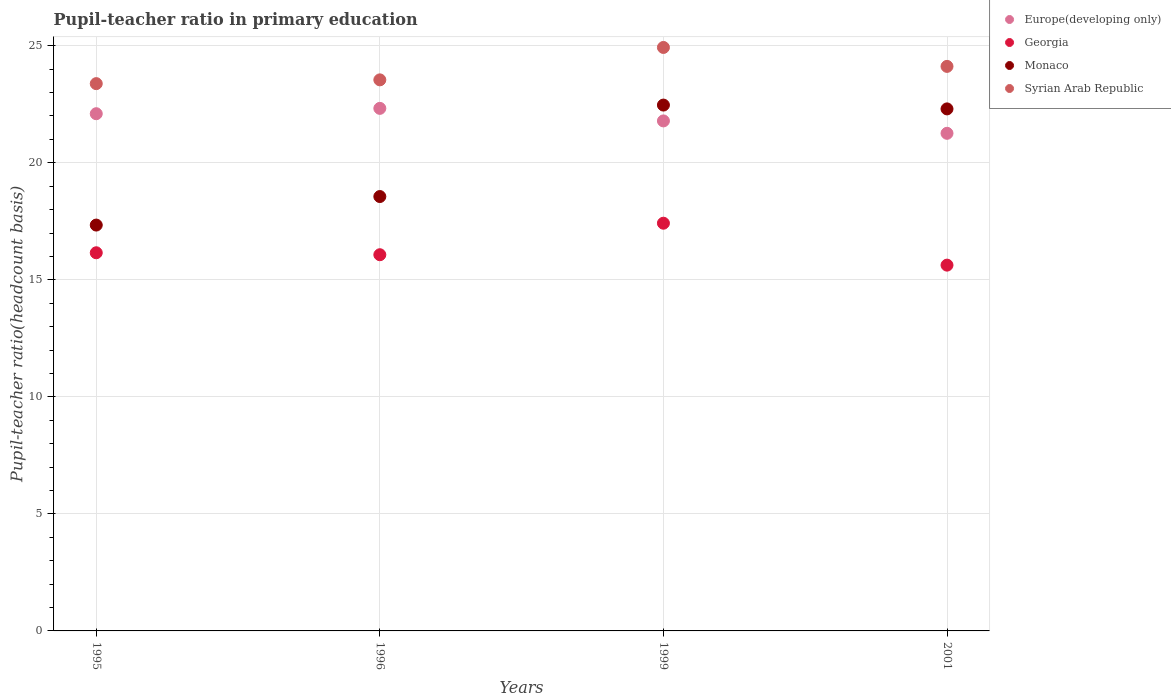What is the pupil-teacher ratio in primary education in Monaco in 2001?
Ensure brevity in your answer.  22.3. Across all years, what is the maximum pupil-teacher ratio in primary education in Syrian Arab Republic?
Keep it short and to the point. 24.93. Across all years, what is the minimum pupil-teacher ratio in primary education in Syrian Arab Republic?
Your response must be concise. 23.38. In which year was the pupil-teacher ratio in primary education in Monaco maximum?
Provide a succinct answer. 1999. What is the total pupil-teacher ratio in primary education in Monaco in the graph?
Offer a very short reply. 80.67. What is the difference between the pupil-teacher ratio in primary education in Europe(developing only) in 1996 and that in 1999?
Offer a terse response. 0.54. What is the difference between the pupil-teacher ratio in primary education in Syrian Arab Republic in 1999 and the pupil-teacher ratio in primary education in Monaco in 1996?
Your response must be concise. 6.37. What is the average pupil-teacher ratio in primary education in Syrian Arab Republic per year?
Ensure brevity in your answer.  23.99. In the year 1996, what is the difference between the pupil-teacher ratio in primary education in Europe(developing only) and pupil-teacher ratio in primary education in Monaco?
Provide a short and direct response. 3.77. What is the ratio of the pupil-teacher ratio in primary education in Georgia in 1995 to that in 2001?
Keep it short and to the point. 1.03. Is the difference between the pupil-teacher ratio in primary education in Europe(developing only) in 1996 and 1999 greater than the difference between the pupil-teacher ratio in primary education in Monaco in 1996 and 1999?
Ensure brevity in your answer.  Yes. What is the difference between the highest and the second highest pupil-teacher ratio in primary education in Europe(developing only)?
Provide a short and direct response. 0.23. What is the difference between the highest and the lowest pupil-teacher ratio in primary education in Syrian Arab Republic?
Provide a short and direct response. 1.55. In how many years, is the pupil-teacher ratio in primary education in Monaco greater than the average pupil-teacher ratio in primary education in Monaco taken over all years?
Make the answer very short. 2. Is the pupil-teacher ratio in primary education in Georgia strictly greater than the pupil-teacher ratio in primary education in Syrian Arab Republic over the years?
Your answer should be very brief. No. Are the values on the major ticks of Y-axis written in scientific E-notation?
Your answer should be compact. No. How many legend labels are there?
Your answer should be compact. 4. What is the title of the graph?
Offer a terse response. Pupil-teacher ratio in primary education. Does "Ukraine" appear as one of the legend labels in the graph?
Offer a terse response. No. What is the label or title of the X-axis?
Your response must be concise. Years. What is the label or title of the Y-axis?
Make the answer very short. Pupil-teacher ratio(headcount basis). What is the Pupil-teacher ratio(headcount basis) of Europe(developing only) in 1995?
Your response must be concise. 22.1. What is the Pupil-teacher ratio(headcount basis) in Georgia in 1995?
Provide a succinct answer. 16.16. What is the Pupil-teacher ratio(headcount basis) of Monaco in 1995?
Make the answer very short. 17.34. What is the Pupil-teacher ratio(headcount basis) in Syrian Arab Republic in 1995?
Provide a short and direct response. 23.38. What is the Pupil-teacher ratio(headcount basis) of Europe(developing only) in 1996?
Your answer should be very brief. 22.33. What is the Pupil-teacher ratio(headcount basis) of Georgia in 1996?
Give a very brief answer. 16.07. What is the Pupil-teacher ratio(headcount basis) in Monaco in 1996?
Your answer should be very brief. 18.56. What is the Pupil-teacher ratio(headcount basis) of Syrian Arab Republic in 1996?
Give a very brief answer. 23.54. What is the Pupil-teacher ratio(headcount basis) of Europe(developing only) in 1999?
Provide a short and direct response. 21.79. What is the Pupil-teacher ratio(headcount basis) of Georgia in 1999?
Give a very brief answer. 17.42. What is the Pupil-teacher ratio(headcount basis) of Monaco in 1999?
Give a very brief answer. 22.47. What is the Pupil-teacher ratio(headcount basis) of Syrian Arab Republic in 1999?
Ensure brevity in your answer.  24.93. What is the Pupil-teacher ratio(headcount basis) of Europe(developing only) in 2001?
Offer a terse response. 21.26. What is the Pupil-teacher ratio(headcount basis) of Georgia in 2001?
Your answer should be compact. 15.63. What is the Pupil-teacher ratio(headcount basis) in Monaco in 2001?
Give a very brief answer. 22.3. What is the Pupil-teacher ratio(headcount basis) in Syrian Arab Republic in 2001?
Your answer should be very brief. 24.12. Across all years, what is the maximum Pupil-teacher ratio(headcount basis) of Europe(developing only)?
Your answer should be very brief. 22.33. Across all years, what is the maximum Pupil-teacher ratio(headcount basis) in Georgia?
Provide a succinct answer. 17.42. Across all years, what is the maximum Pupil-teacher ratio(headcount basis) of Monaco?
Offer a terse response. 22.47. Across all years, what is the maximum Pupil-teacher ratio(headcount basis) of Syrian Arab Republic?
Make the answer very short. 24.93. Across all years, what is the minimum Pupil-teacher ratio(headcount basis) of Europe(developing only)?
Keep it short and to the point. 21.26. Across all years, what is the minimum Pupil-teacher ratio(headcount basis) in Georgia?
Offer a very short reply. 15.63. Across all years, what is the minimum Pupil-teacher ratio(headcount basis) of Monaco?
Offer a terse response. 17.34. Across all years, what is the minimum Pupil-teacher ratio(headcount basis) of Syrian Arab Republic?
Offer a very short reply. 23.38. What is the total Pupil-teacher ratio(headcount basis) of Europe(developing only) in the graph?
Ensure brevity in your answer.  87.47. What is the total Pupil-teacher ratio(headcount basis) of Georgia in the graph?
Your answer should be very brief. 65.28. What is the total Pupil-teacher ratio(headcount basis) of Monaco in the graph?
Make the answer very short. 80.67. What is the total Pupil-teacher ratio(headcount basis) of Syrian Arab Republic in the graph?
Provide a succinct answer. 95.97. What is the difference between the Pupil-teacher ratio(headcount basis) of Europe(developing only) in 1995 and that in 1996?
Your response must be concise. -0.23. What is the difference between the Pupil-teacher ratio(headcount basis) of Georgia in 1995 and that in 1996?
Give a very brief answer. 0.08. What is the difference between the Pupil-teacher ratio(headcount basis) in Monaco in 1995 and that in 1996?
Make the answer very short. -1.22. What is the difference between the Pupil-teacher ratio(headcount basis) of Syrian Arab Republic in 1995 and that in 1996?
Give a very brief answer. -0.16. What is the difference between the Pupil-teacher ratio(headcount basis) in Europe(developing only) in 1995 and that in 1999?
Ensure brevity in your answer.  0.31. What is the difference between the Pupil-teacher ratio(headcount basis) in Georgia in 1995 and that in 1999?
Your response must be concise. -1.26. What is the difference between the Pupil-teacher ratio(headcount basis) in Monaco in 1995 and that in 1999?
Offer a very short reply. -5.13. What is the difference between the Pupil-teacher ratio(headcount basis) in Syrian Arab Republic in 1995 and that in 1999?
Make the answer very short. -1.55. What is the difference between the Pupil-teacher ratio(headcount basis) of Europe(developing only) in 1995 and that in 2001?
Provide a short and direct response. 0.84. What is the difference between the Pupil-teacher ratio(headcount basis) of Georgia in 1995 and that in 2001?
Offer a terse response. 0.53. What is the difference between the Pupil-teacher ratio(headcount basis) of Monaco in 1995 and that in 2001?
Offer a very short reply. -4.96. What is the difference between the Pupil-teacher ratio(headcount basis) in Syrian Arab Republic in 1995 and that in 2001?
Keep it short and to the point. -0.74. What is the difference between the Pupil-teacher ratio(headcount basis) in Europe(developing only) in 1996 and that in 1999?
Provide a short and direct response. 0.54. What is the difference between the Pupil-teacher ratio(headcount basis) in Georgia in 1996 and that in 1999?
Keep it short and to the point. -1.35. What is the difference between the Pupil-teacher ratio(headcount basis) of Monaco in 1996 and that in 1999?
Your answer should be very brief. -3.91. What is the difference between the Pupil-teacher ratio(headcount basis) in Syrian Arab Republic in 1996 and that in 1999?
Provide a short and direct response. -1.38. What is the difference between the Pupil-teacher ratio(headcount basis) of Europe(developing only) in 1996 and that in 2001?
Keep it short and to the point. 1.07. What is the difference between the Pupil-teacher ratio(headcount basis) of Georgia in 1996 and that in 2001?
Your response must be concise. 0.44. What is the difference between the Pupil-teacher ratio(headcount basis) in Monaco in 1996 and that in 2001?
Provide a succinct answer. -3.74. What is the difference between the Pupil-teacher ratio(headcount basis) of Syrian Arab Republic in 1996 and that in 2001?
Give a very brief answer. -0.58. What is the difference between the Pupil-teacher ratio(headcount basis) in Europe(developing only) in 1999 and that in 2001?
Give a very brief answer. 0.53. What is the difference between the Pupil-teacher ratio(headcount basis) of Georgia in 1999 and that in 2001?
Provide a short and direct response. 1.79. What is the difference between the Pupil-teacher ratio(headcount basis) of Monaco in 1999 and that in 2001?
Your response must be concise. 0.16. What is the difference between the Pupil-teacher ratio(headcount basis) of Syrian Arab Republic in 1999 and that in 2001?
Your response must be concise. 0.81. What is the difference between the Pupil-teacher ratio(headcount basis) in Europe(developing only) in 1995 and the Pupil-teacher ratio(headcount basis) in Georgia in 1996?
Provide a succinct answer. 6.02. What is the difference between the Pupil-teacher ratio(headcount basis) of Europe(developing only) in 1995 and the Pupil-teacher ratio(headcount basis) of Monaco in 1996?
Offer a terse response. 3.54. What is the difference between the Pupil-teacher ratio(headcount basis) in Europe(developing only) in 1995 and the Pupil-teacher ratio(headcount basis) in Syrian Arab Republic in 1996?
Offer a terse response. -1.45. What is the difference between the Pupil-teacher ratio(headcount basis) in Georgia in 1995 and the Pupil-teacher ratio(headcount basis) in Monaco in 1996?
Give a very brief answer. -2.4. What is the difference between the Pupil-teacher ratio(headcount basis) in Georgia in 1995 and the Pupil-teacher ratio(headcount basis) in Syrian Arab Republic in 1996?
Ensure brevity in your answer.  -7.39. What is the difference between the Pupil-teacher ratio(headcount basis) of Monaco in 1995 and the Pupil-teacher ratio(headcount basis) of Syrian Arab Republic in 1996?
Ensure brevity in your answer.  -6.2. What is the difference between the Pupil-teacher ratio(headcount basis) in Europe(developing only) in 1995 and the Pupil-teacher ratio(headcount basis) in Georgia in 1999?
Keep it short and to the point. 4.68. What is the difference between the Pupil-teacher ratio(headcount basis) in Europe(developing only) in 1995 and the Pupil-teacher ratio(headcount basis) in Monaco in 1999?
Make the answer very short. -0.37. What is the difference between the Pupil-teacher ratio(headcount basis) in Europe(developing only) in 1995 and the Pupil-teacher ratio(headcount basis) in Syrian Arab Republic in 1999?
Make the answer very short. -2.83. What is the difference between the Pupil-teacher ratio(headcount basis) of Georgia in 1995 and the Pupil-teacher ratio(headcount basis) of Monaco in 1999?
Offer a terse response. -6.31. What is the difference between the Pupil-teacher ratio(headcount basis) of Georgia in 1995 and the Pupil-teacher ratio(headcount basis) of Syrian Arab Republic in 1999?
Your response must be concise. -8.77. What is the difference between the Pupil-teacher ratio(headcount basis) in Monaco in 1995 and the Pupil-teacher ratio(headcount basis) in Syrian Arab Republic in 1999?
Offer a terse response. -7.59. What is the difference between the Pupil-teacher ratio(headcount basis) of Europe(developing only) in 1995 and the Pupil-teacher ratio(headcount basis) of Georgia in 2001?
Provide a succinct answer. 6.47. What is the difference between the Pupil-teacher ratio(headcount basis) of Europe(developing only) in 1995 and the Pupil-teacher ratio(headcount basis) of Monaco in 2001?
Make the answer very short. -0.21. What is the difference between the Pupil-teacher ratio(headcount basis) in Europe(developing only) in 1995 and the Pupil-teacher ratio(headcount basis) in Syrian Arab Republic in 2001?
Ensure brevity in your answer.  -2.02. What is the difference between the Pupil-teacher ratio(headcount basis) of Georgia in 1995 and the Pupil-teacher ratio(headcount basis) of Monaco in 2001?
Provide a succinct answer. -6.15. What is the difference between the Pupil-teacher ratio(headcount basis) of Georgia in 1995 and the Pupil-teacher ratio(headcount basis) of Syrian Arab Republic in 2001?
Offer a terse response. -7.96. What is the difference between the Pupil-teacher ratio(headcount basis) in Monaco in 1995 and the Pupil-teacher ratio(headcount basis) in Syrian Arab Republic in 2001?
Provide a short and direct response. -6.78. What is the difference between the Pupil-teacher ratio(headcount basis) of Europe(developing only) in 1996 and the Pupil-teacher ratio(headcount basis) of Georgia in 1999?
Your answer should be compact. 4.91. What is the difference between the Pupil-teacher ratio(headcount basis) in Europe(developing only) in 1996 and the Pupil-teacher ratio(headcount basis) in Monaco in 1999?
Offer a very short reply. -0.14. What is the difference between the Pupil-teacher ratio(headcount basis) of Europe(developing only) in 1996 and the Pupil-teacher ratio(headcount basis) of Syrian Arab Republic in 1999?
Offer a terse response. -2.6. What is the difference between the Pupil-teacher ratio(headcount basis) in Georgia in 1996 and the Pupil-teacher ratio(headcount basis) in Monaco in 1999?
Provide a short and direct response. -6.39. What is the difference between the Pupil-teacher ratio(headcount basis) of Georgia in 1996 and the Pupil-teacher ratio(headcount basis) of Syrian Arab Republic in 1999?
Make the answer very short. -8.86. What is the difference between the Pupil-teacher ratio(headcount basis) in Monaco in 1996 and the Pupil-teacher ratio(headcount basis) in Syrian Arab Republic in 1999?
Your answer should be compact. -6.37. What is the difference between the Pupil-teacher ratio(headcount basis) of Europe(developing only) in 1996 and the Pupil-teacher ratio(headcount basis) of Georgia in 2001?
Your answer should be very brief. 6.7. What is the difference between the Pupil-teacher ratio(headcount basis) of Europe(developing only) in 1996 and the Pupil-teacher ratio(headcount basis) of Monaco in 2001?
Make the answer very short. 0.02. What is the difference between the Pupil-teacher ratio(headcount basis) of Europe(developing only) in 1996 and the Pupil-teacher ratio(headcount basis) of Syrian Arab Republic in 2001?
Offer a terse response. -1.79. What is the difference between the Pupil-teacher ratio(headcount basis) in Georgia in 1996 and the Pupil-teacher ratio(headcount basis) in Monaco in 2001?
Offer a terse response. -6.23. What is the difference between the Pupil-teacher ratio(headcount basis) in Georgia in 1996 and the Pupil-teacher ratio(headcount basis) in Syrian Arab Republic in 2001?
Make the answer very short. -8.05. What is the difference between the Pupil-teacher ratio(headcount basis) of Monaco in 1996 and the Pupil-teacher ratio(headcount basis) of Syrian Arab Republic in 2001?
Make the answer very short. -5.56. What is the difference between the Pupil-teacher ratio(headcount basis) in Europe(developing only) in 1999 and the Pupil-teacher ratio(headcount basis) in Georgia in 2001?
Offer a terse response. 6.16. What is the difference between the Pupil-teacher ratio(headcount basis) of Europe(developing only) in 1999 and the Pupil-teacher ratio(headcount basis) of Monaco in 2001?
Your answer should be very brief. -0.51. What is the difference between the Pupil-teacher ratio(headcount basis) of Europe(developing only) in 1999 and the Pupil-teacher ratio(headcount basis) of Syrian Arab Republic in 2001?
Make the answer very short. -2.33. What is the difference between the Pupil-teacher ratio(headcount basis) in Georgia in 1999 and the Pupil-teacher ratio(headcount basis) in Monaco in 2001?
Your answer should be very brief. -4.88. What is the difference between the Pupil-teacher ratio(headcount basis) in Georgia in 1999 and the Pupil-teacher ratio(headcount basis) in Syrian Arab Republic in 2001?
Your answer should be compact. -6.7. What is the difference between the Pupil-teacher ratio(headcount basis) of Monaco in 1999 and the Pupil-teacher ratio(headcount basis) of Syrian Arab Republic in 2001?
Provide a short and direct response. -1.65. What is the average Pupil-teacher ratio(headcount basis) of Europe(developing only) per year?
Make the answer very short. 21.87. What is the average Pupil-teacher ratio(headcount basis) in Georgia per year?
Your answer should be very brief. 16.32. What is the average Pupil-teacher ratio(headcount basis) in Monaco per year?
Provide a short and direct response. 20.17. What is the average Pupil-teacher ratio(headcount basis) in Syrian Arab Republic per year?
Ensure brevity in your answer.  23.99. In the year 1995, what is the difference between the Pupil-teacher ratio(headcount basis) in Europe(developing only) and Pupil-teacher ratio(headcount basis) in Georgia?
Offer a very short reply. 5.94. In the year 1995, what is the difference between the Pupil-teacher ratio(headcount basis) in Europe(developing only) and Pupil-teacher ratio(headcount basis) in Monaco?
Make the answer very short. 4.76. In the year 1995, what is the difference between the Pupil-teacher ratio(headcount basis) in Europe(developing only) and Pupil-teacher ratio(headcount basis) in Syrian Arab Republic?
Ensure brevity in your answer.  -1.29. In the year 1995, what is the difference between the Pupil-teacher ratio(headcount basis) in Georgia and Pupil-teacher ratio(headcount basis) in Monaco?
Ensure brevity in your answer.  -1.18. In the year 1995, what is the difference between the Pupil-teacher ratio(headcount basis) of Georgia and Pupil-teacher ratio(headcount basis) of Syrian Arab Republic?
Provide a succinct answer. -7.23. In the year 1995, what is the difference between the Pupil-teacher ratio(headcount basis) of Monaco and Pupil-teacher ratio(headcount basis) of Syrian Arab Republic?
Provide a succinct answer. -6.04. In the year 1996, what is the difference between the Pupil-teacher ratio(headcount basis) in Europe(developing only) and Pupil-teacher ratio(headcount basis) in Georgia?
Ensure brevity in your answer.  6.25. In the year 1996, what is the difference between the Pupil-teacher ratio(headcount basis) of Europe(developing only) and Pupil-teacher ratio(headcount basis) of Monaco?
Give a very brief answer. 3.77. In the year 1996, what is the difference between the Pupil-teacher ratio(headcount basis) of Europe(developing only) and Pupil-teacher ratio(headcount basis) of Syrian Arab Republic?
Provide a succinct answer. -1.22. In the year 1996, what is the difference between the Pupil-teacher ratio(headcount basis) of Georgia and Pupil-teacher ratio(headcount basis) of Monaco?
Offer a very short reply. -2.49. In the year 1996, what is the difference between the Pupil-teacher ratio(headcount basis) of Georgia and Pupil-teacher ratio(headcount basis) of Syrian Arab Republic?
Your answer should be compact. -7.47. In the year 1996, what is the difference between the Pupil-teacher ratio(headcount basis) in Monaco and Pupil-teacher ratio(headcount basis) in Syrian Arab Republic?
Your answer should be very brief. -4.99. In the year 1999, what is the difference between the Pupil-teacher ratio(headcount basis) in Europe(developing only) and Pupil-teacher ratio(headcount basis) in Georgia?
Offer a terse response. 4.37. In the year 1999, what is the difference between the Pupil-teacher ratio(headcount basis) in Europe(developing only) and Pupil-teacher ratio(headcount basis) in Monaco?
Keep it short and to the point. -0.68. In the year 1999, what is the difference between the Pupil-teacher ratio(headcount basis) of Europe(developing only) and Pupil-teacher ratio(headcount basis) of Syrian Arab Republic?
Offer a very short reply. -3.14. In the year 1999, what is the difference between the Pupil-teacher ratio(headcount basis) of Georgia and Pupil-teacher ratio(headcount basis) of Monaco?
Offer a terse response. -5.05. In the year 1999, what is the difference between the Pupil-teacher ratio(headcount basis) in Georgia and Pupil-teacher ratio(headcount basis) in Syrian Arab Republic?
Your answer should be very brief. -7.51. In the year 1999, what is the difference between the Pupil-teacher ratio(headcount basis) of Monaco and Pupil-teacher ratio(headcount basis) of Syrian Arab Republic?
Offer a terse response. -2.46. In the year 2001, what is the difference between the Pupil-teacher ratio(headcount basis) of Europe(developing only) and Pupil-teacher ratio(headcount basis) of Georgia?
Your answer should be very brief. 5.63. In the year 2001, what is the difference between the Pupil-teacher ratio(headcount basis) of Europe(developing only) and Pupil-teacher ratio(headcount basis) of Monaco?
Provide a succinct answer. -1.04. In the year 2001, what is the difference between the Pupil-teacher ratio(headcount basis) of Europe(developing only) and Pupil-teacher ratio(headcount basis) of Syrian Arab Republic?
Your answer should be compact. -2.86. In the year 2001, what is the difference between the Pupil-teacher ratio(headcount basis) in Georgia and Pupil-teacher ratio(headcount basis) in Monaco?
Give a very brief answer. -6.68. In the year 2001, what is the difference between the Pupil-teacher ratio(headcount basis) of Georgia and Pupil-teacher ratio(headcount basis) of Syrian Arab Republic?
Offer a very short reply. -8.49. In the year 2001, what is the difference between the Pupil-teacher ratio(headcount basis) in Monaco and Pupil-teacher ratio(headcount basis) in Syrian Arab Republic?
Ensure brevity in your answer.  -1.82. What is the ratio of the Pupil-teacher ratio(headcount basis) in Europe(developing only) in 1995 to that in 1996?
Your answer should be compact. 0.99. What is the ratio of the Pupil-teacher ratio(headcount basis) in Georgia in 1995 to that in 1996?
Provide a succinct answer. 1.01. What is the ratio of the Pupil-teacher ratio(headcount basis) of Monaco in 1995 to that in 1996?
Ensure brevity in your answer.  0.93. What is the ratio of the Pupil-teacher ratio(headcount basis) in Syrian Arab Republic in 1995 to that in 1996?
Give a very brief answer. 0.99. What is the ratio of the Pupil-teacher ratio(headcount basis) of Europe(developing only) in 1995 to that in 1999?
Make the answer very short. 1.01. What is the ratio of the Pupil-teacher ratio(headcount basis) of Georgia in 1995 to that in 1999?
Make the answer very short. 0.93. What is the ratio of the Pupil-teacher ratio(headcount basis) of Monaco in 1995 to that in 1999?
Your answer should be compact. 0.77. What is the ratio of the Pupil-teacher ratio(headcount basis) of Syrian Arab Republic in 1995 to that in 1999?
Make the answer very short. 0.94. What is the ratio of the Pupil-teacher ratio(headcount basis) of Europe(developing only) in 1995 to that in 2001?
Ensure brevity in your answer.  1.04. What is the ratio of the Pupil-teacher ratio(headcount basis) of Georgia in 1995 to that in 2001?
Provide a succinct answer. 1.03. What is the ratio of the Pupil-teacher ratio(headcount basis) of Monaco in 1995 to that in 2001?
Your answer should be compact. 0.78. What is the ratio of the Pupil-teacher ratio(headcount basis) of Syrian Arab Republic in 1995 to that in 2001?
Give a very brief answer. 0.97. What is the ratio of the Pupil-teacher ratio(headcount basis) in Europe(developing only) in 1996 to that in 1999?
Your answer should be compact. 1.02. What is the ratio of the Pupil-teacher ratio(headcount basis) in Georgia in 1996 to that in 1999?
Ensure brevity in your answer.  0.92. What is the ratio of the Pupil-teacher ratio(headcount basis) of Monaco in 1996 to that in 1999?
Your answer should be compact. 0.83. What is the ratio of the Pupil-teacher ratio(headcount basis) in Syrian Arab Republic in 1996 to that in 1999?
Keep it short and to the point. 0.94. What is the ratio of the Pupil-teacher ratio(headcount basis) in Europe(developing only) in 1996 to that in 2001?
Your answer should be very brief. 1.05. What is the ratio of the Pupil-teacher ratio(headcount basis) in Georgia in 1996 to that in 2001?
Make the answer very short. 1.03. What is the ratio of the Pupil-teacher ratio(headcount basis) in Monaco in 1996 to that in 2001?
Offer a terse response. 0.83. What is the ratio of the Pupil-teacher ratio(headcount basis) of Syrian Arab Republic in 1996 to that in 2001?
Keep it short and to the point. 0.98. What is the ratio of the Pupil-teacher ratio(headcount basis) of Europe(developing only) in 1999 to that in 2001?
Make the answer very short. 1.02. What is the ratio of the Pupil-teacher ratio(headcount basis) in Georgia in 1999 to that in 2001?
Make the answer very short. 1.11. What is the ratio of the Pupil-teacher ratio(headcount basis) in Monaco in 1999 to that in 2001?
Provide a succinct answer. 1.01. What is the ratio of the Pupil-teacher ratio(headcount basis) of Syrian Arab Republic in 1999 to that in 2001?
Provide a short and direct response. 1.03. What is the difference between the highest and the second highest Pupil-teacher ratio(headcount basis) in Europe(developing only)?
Provide a succinct answer. 0.23. What is the difference between the highest and the second highest Pupil-teacher ratio(headcount basis) in Georgia?
Ensure brevity in your answer.  1.26. What is the difference between the highest and the second highest Pupil-teacher ratio(headcount basis) of Monaco?
Offer a terse response. 0.16. What is the difference between the highest and the second highest Pupil-teacher ratio(headcount basis) in Syrian Arab Republic?
Offer a very short reply. 0.81. What is the difference between the highest and the lowest Pupil-teacher ratio(headcount basis) in Europe(developing only)?
Keep it short and to the point. 1.07. What is the difference between the highest and the lowest Pupil-teacher ratio(headcount basis) in Georgia?
Your answer should be compact. 1.79. What is the difference between the highest and the lowest Pupil-teacher ratio(headcount basis) in Monaco?
Your answer should be very brief. 5.13. What is the difference between the highest and the lowest Pupil-teacher ratio(headcount basis) in Syrian Arab Republic?
Keep it short and to the point. 1.55. 